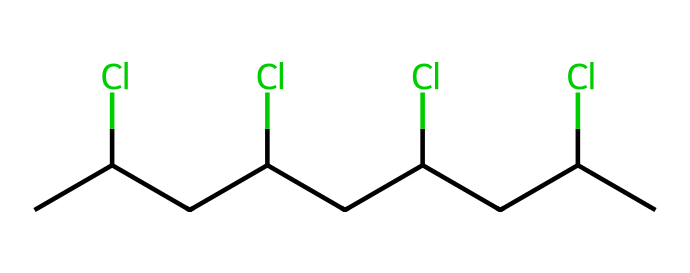What is the number of chlorine atoms in the chemical structure? The SMILES representation shows "CC(Cl)CC(Cl)CC(Cl)CC(Cl)C", indicating there are four occurrences of "(Cl)", which signifies four chlorine atoms.
Answer: four What is the total number of carbon atoms in this structure? By analyzing the SMILES, we count each "C" in the chain: there are ten carbon atoms in total.
Answer: ten Which type of bonds are present between the carbon atoms? The structure indicates carbon atoms are connected by single bonds since the representation does not depict any double or triple bonds.
Answer: single What functional group is represented in this chemical structure? The presence of "(Cl)" indicates the presence of a haloalkane functional group due to the chlorine substituents on the carbon chain.
Answer: haloalkane How many hydrogen atoms would typically be bonded to this structure considering the chlorine substituents? A saturated alkane with ten carbons (C10) would typically have 22 hydrogens (C_nH_(2n+2)). However, due to four chlorines replacing hydrogens, we would have 18 hydrogens (22 - 4 = 18).
Answer: eighteen What is the degree of unsaturation in this chemical structure? Each chlorine atom replaces one hydrogen, but there are no double or triple bonds, resulting in a degree of unsaturation of zero.
Answer: zero What impact do the chlorine atoms have on the physical properties of the polymer? Chlorine atoms increase the density and reduce the volatility, impacting the physical properties and the stability of the polymer.
Answer: increase density 